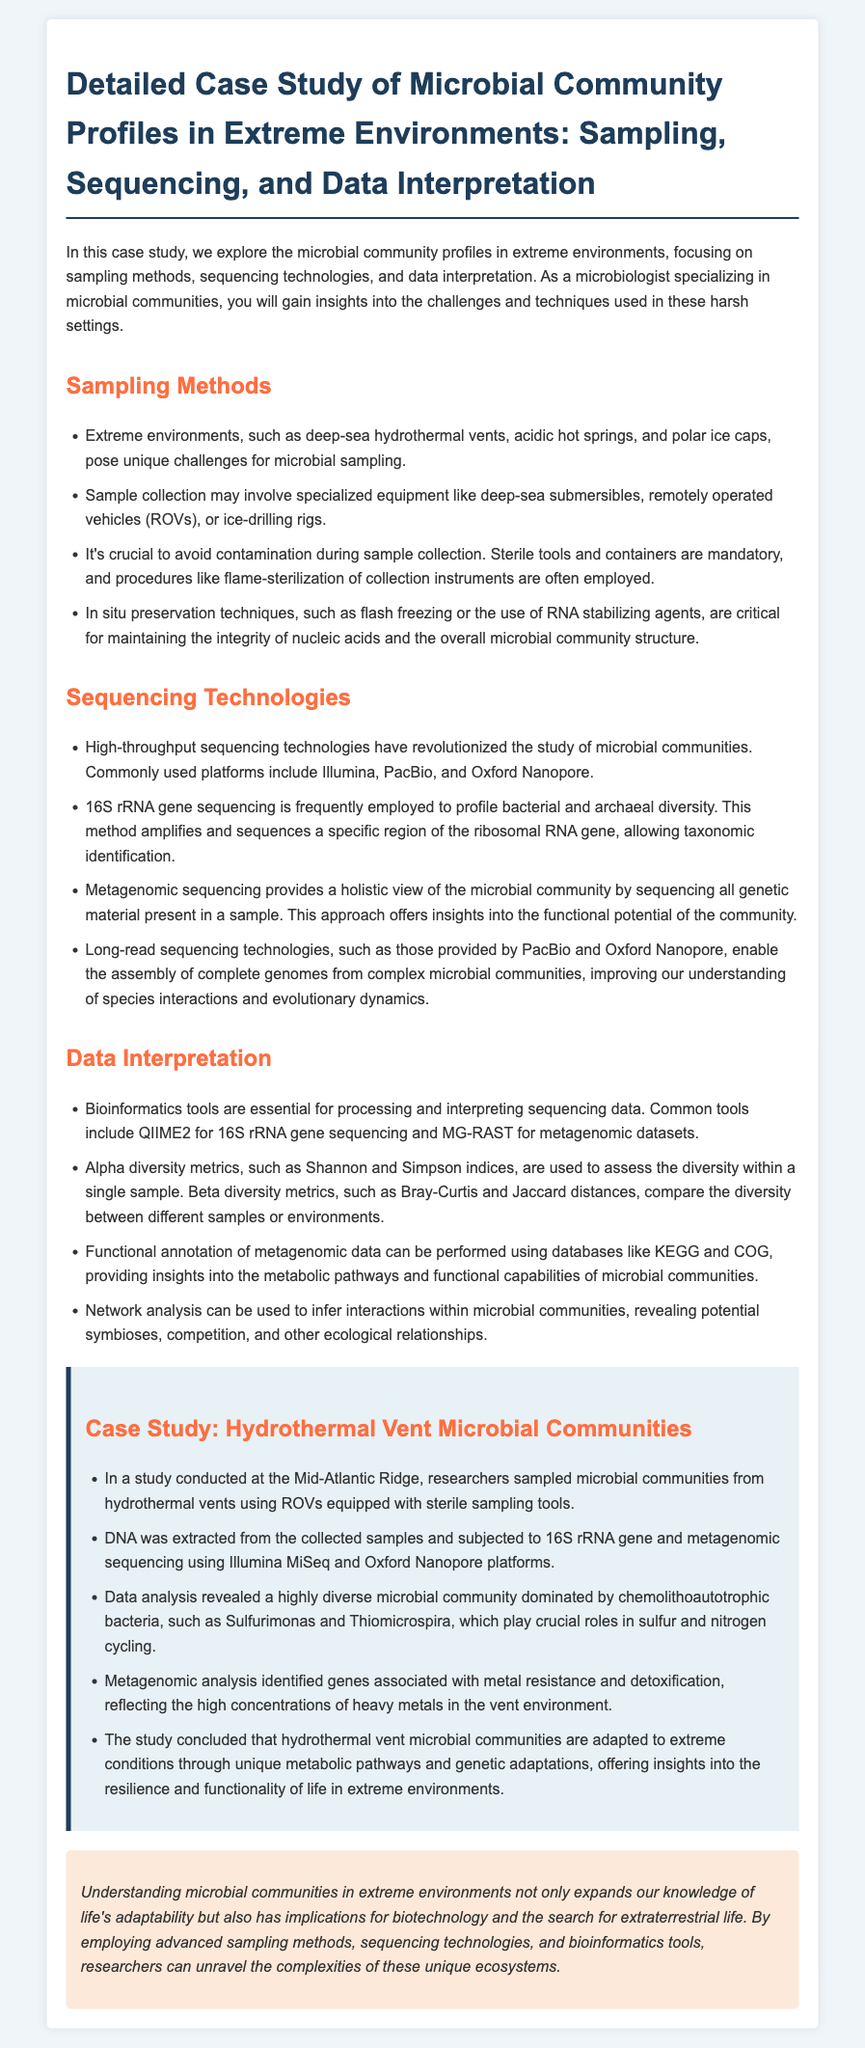What is the focus of the case study? The case study explores microbial community profiles in extreme environments, including sampling methods, sequencing technologies, and data interpretation.
Answer: Microbial community profiles in extreme environments What sampling methods are mentioned? The document lists techniques relevant for sampling in extreme environments, which includes using specialized equipment and sterile procedures.
Answer: Specialized equipment and sterile procedures Which sequencing technology is frequently employed for profiling? The document states that 16S rRNA gene sequencing is commonly used for taxonomic identification in microbial studies.
Answer: 16S rRNA gene sequencing What is the dominant type of bacteria identified in the hydrothermal vent study? The analysis revealed that the microbial community was dominated by chemolithoautotrophic bacteria such as Sulfurimonas and Thiomicrospira.
Answer: Chemolithoautotrophic bacteria What bioinformatics tool is used for 16S rRNA gene sequencing? QIIME2 is identified as a bioinformatics tool essential for processing and interpreting 16S rRNA gene sequencing data.
Answer: QIIME2 What is the significance of metagenomic analysis in the study? The analysis helps in identifying genes associated with specific metabolic processes and the functional capabilities of the microbial community.
Answer: Identifying genes and functional capabilities How do extreme hydrothermal vent conditions affect microbial communities? Researchers concluded that microbial communities are adapted to extreme conditions through unique metabolic pathways and genetic adaptations.
Answer: Adaptation through unique metabolic pathways What conclusion is drawn about life in extreme environments? The document highlights that understanding microbial communities expands knowledge of life's adaptability and has implications for biotechnology and extraterrestrial life.
Answer: Expands knowledge of life's adaptability 